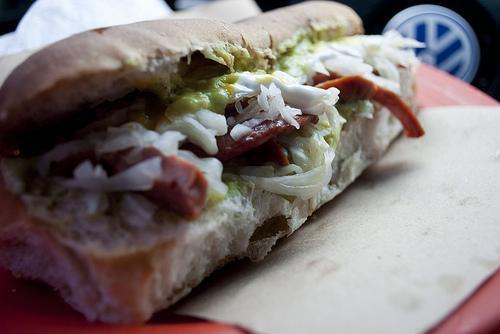How many sandwiches are there?
Give a very brief answer. 1. 